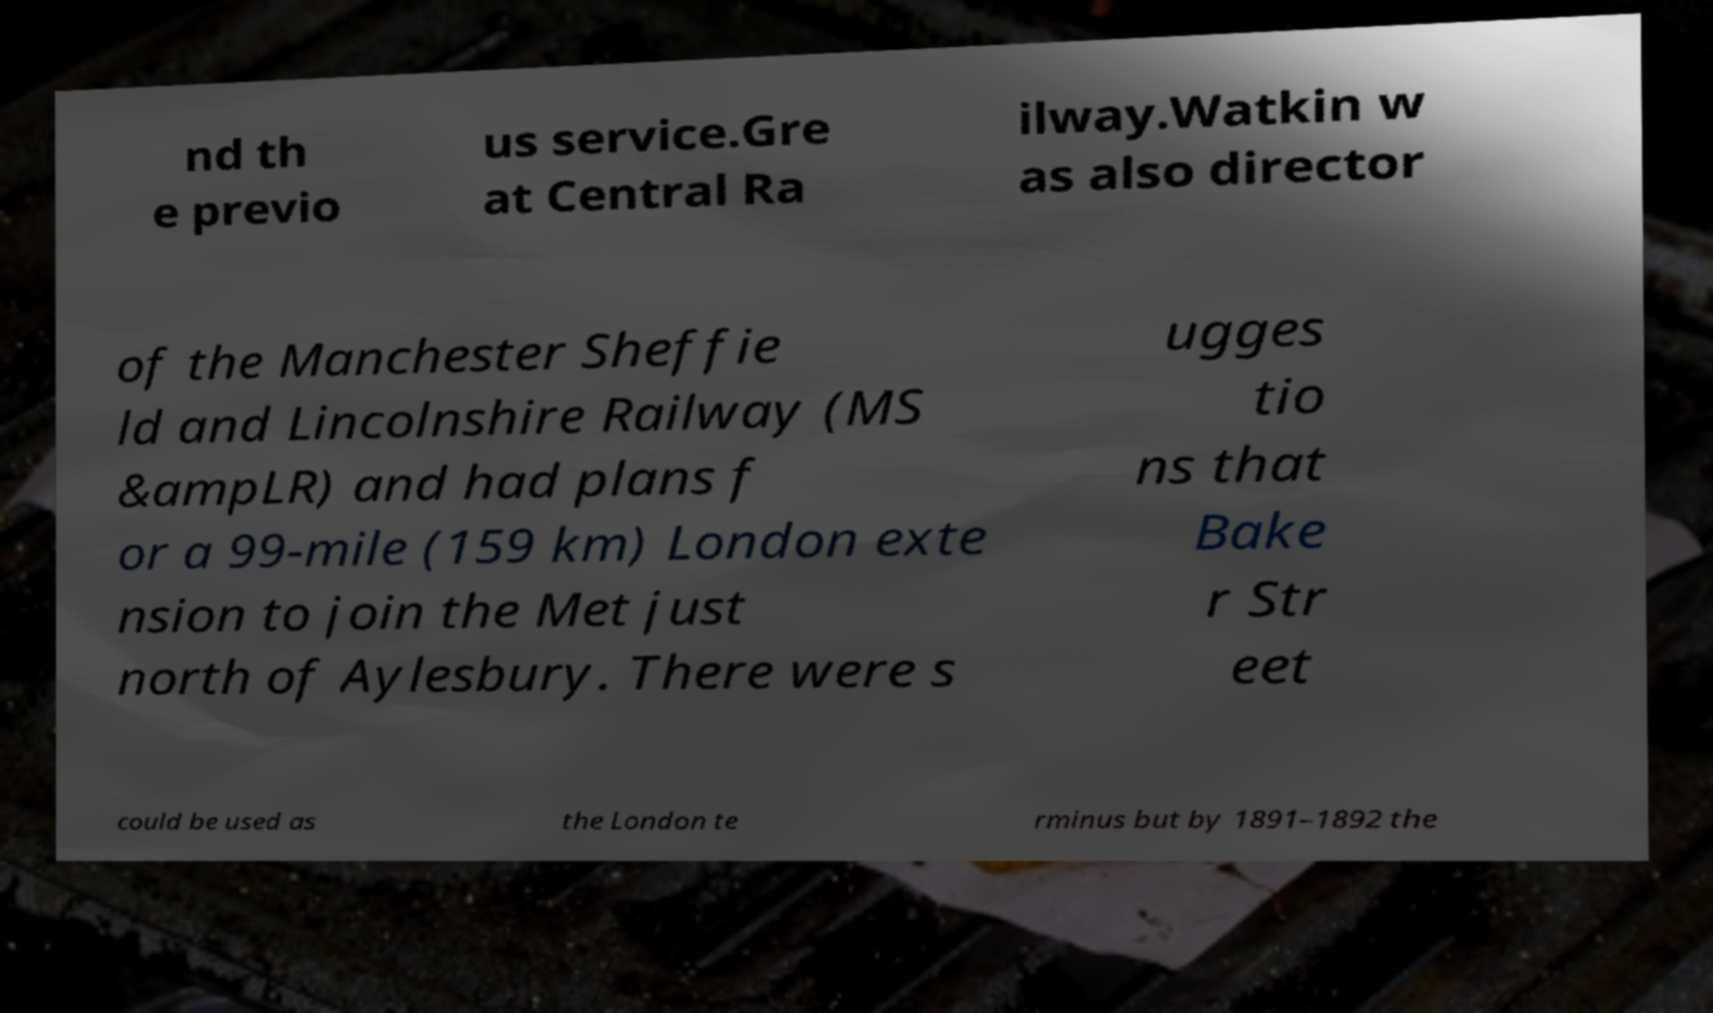Can you accurately transcribe the text from the provided image for me? nd th e previo us service.Gre at Central Ra ilway.Watkin w as also director of the Manchester Sheffie ld and Lincolnshire Railway (MS &ampLR) and had plans f or a 99-mile (159 km) London exte nsion to join the Met just north of Aylesbury. There were s ugges tio ns that Bake r Str eet could be used as the London te rminus but by 1891–1892 the 